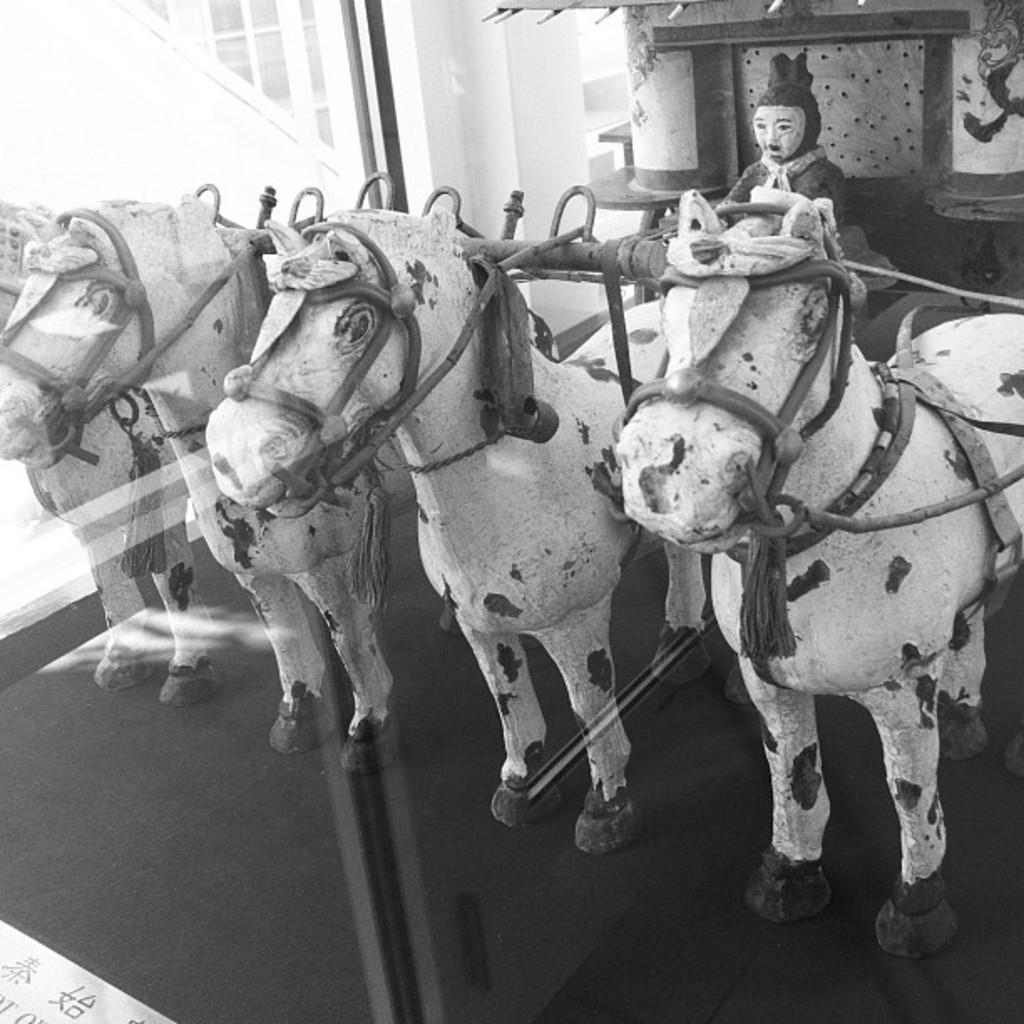What animals are depicted in the image? There are horses depicted in the image. Are there any human figures in the image? Yes, there is a person depicted in the image. What architectural elements can be seen in the image? There is a window, a pillar, and a wall in the image. What type of surface is visible in the image? There is a floor in the image. What is the color scheme of the image? The image is black and white. What type of ball is being used by the person in the image? There is no ball present in the image; it features horses, a person, and various architectural elements. What time is it according to the clock in the image? There is no clock present in the image. 